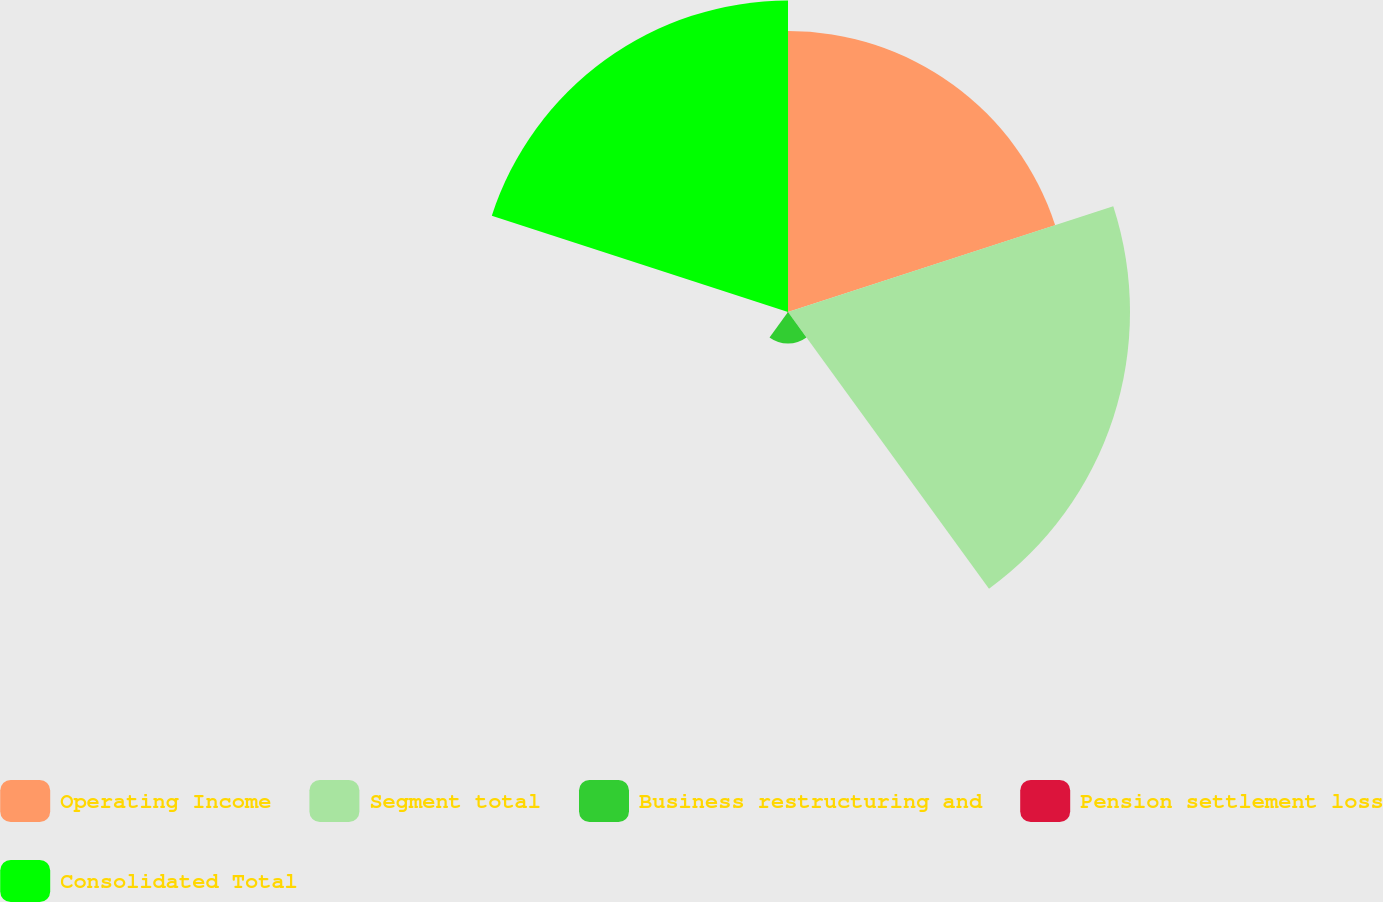Convert chart to OTSL. <chart><loc_0><loc_0><loc_500><loc_500><pie_chart><fcel>Operating Income<fcel>Segment total<fcel>Business restructuring and<fcel>Pension settlement loss<fcel>Consolidated Total<nl><fcel>29.06%<fcel>35.38%<fcel>3.25%<fcel>0.09%<fcel>32.22%<nl></chart> 